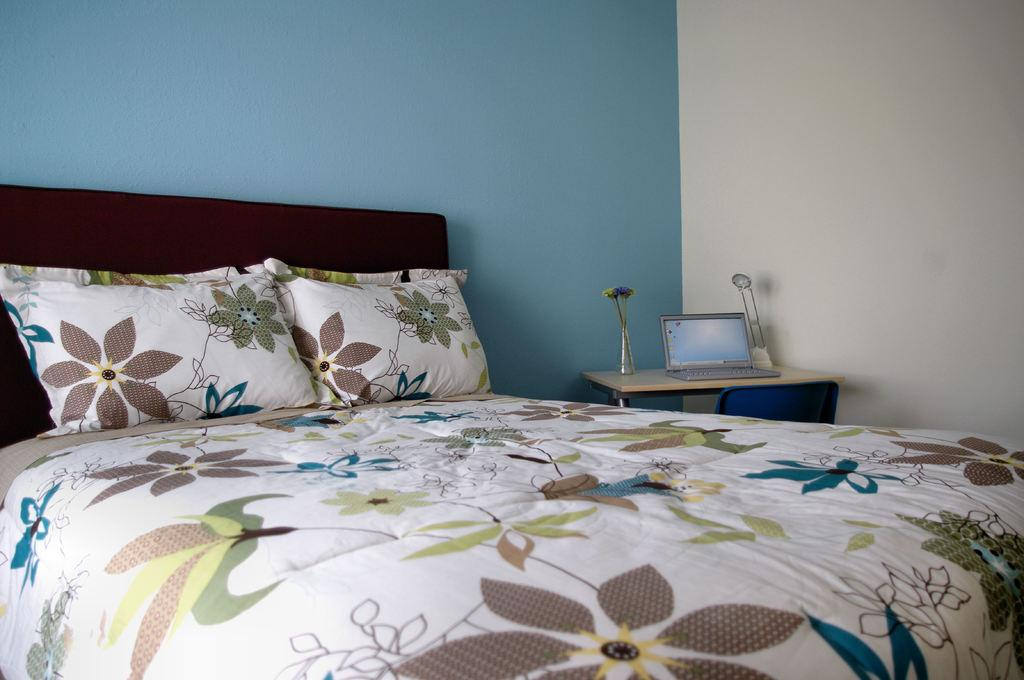What piece of furniture is the main subject in the image? There is a bed in the image. What is placed on the bed? There are two pillows on the bed. What electronic device is on the table? There is a laptop on the table. What decorative item can be seen on the table? There is a flower in a vase on the table. What light source is present in the image? There is a lamp on the table. What other piece of furniture is in the room? There is a chair in the image. How many pizzas are being served on the table in the image? There are no pizzas present in the image. What type of military vehicle can be seen in the image? There is no military vehicle, such as a tank, present in the image. 